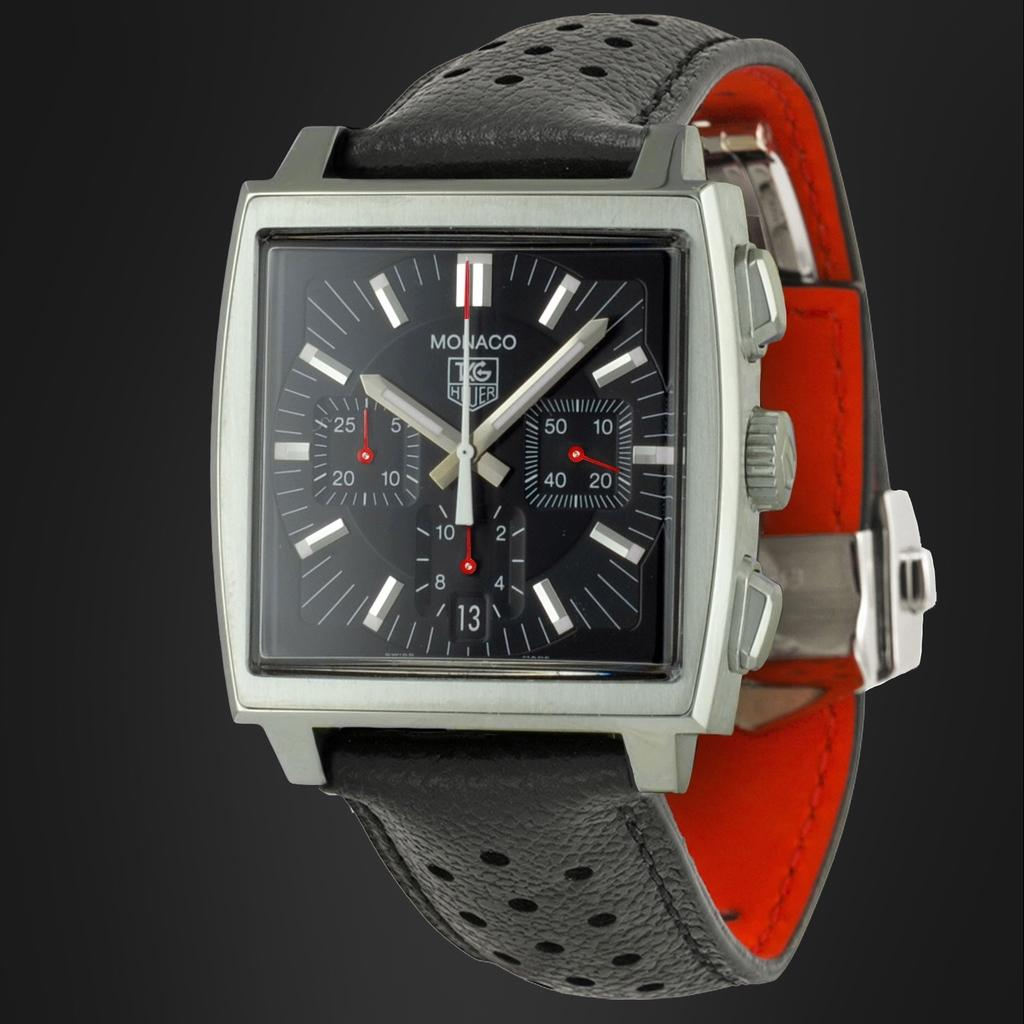<image>
Relay a brief, clear account of the picture shown. Black and orange wristwatch that says MONACO on the face. 